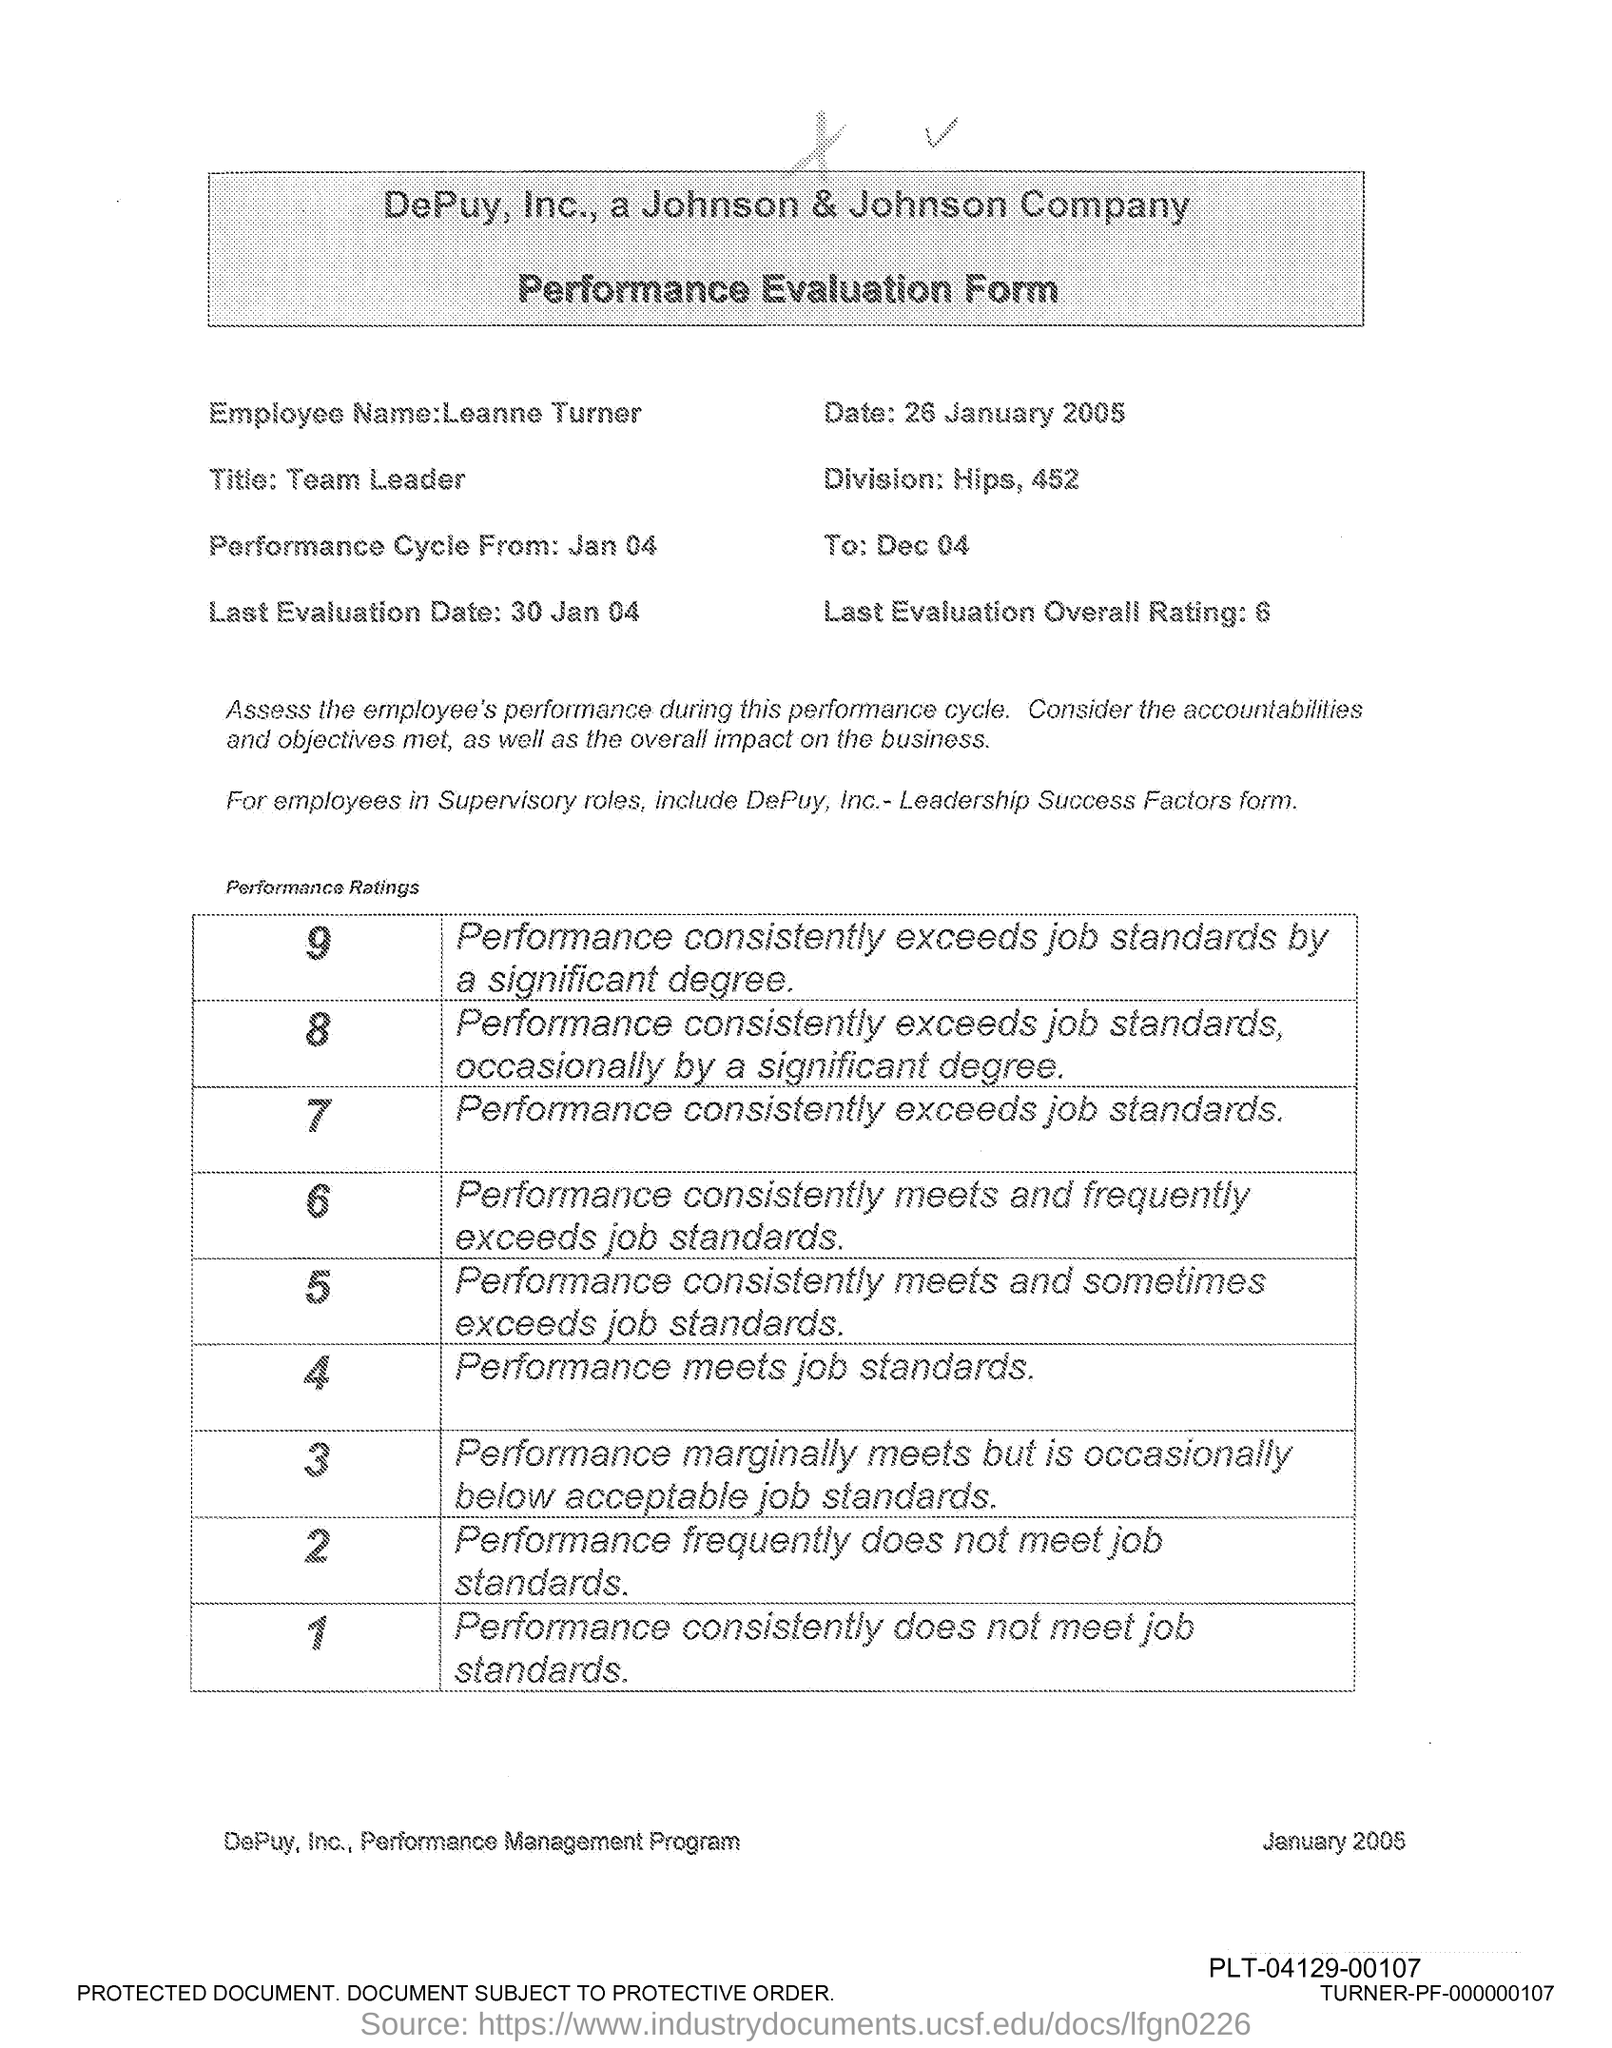What is the name of the Employee?
Provide a succinct answer. Leanne Turner. 